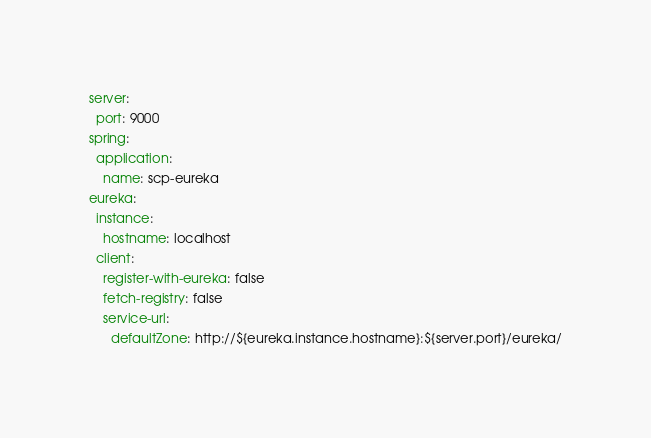<code> <loc_0><loc_0><loc_500><loc_500><_YAML_>server:
  port: 9000
spring:
  application:
    name: scp-eureka
eureka:
  instance:
    hostname: localhost
  client:
    register-with-eureka: false
    fetch-registry: false
    service-url:
      defaultZone: http://${eureka.instance.hostname}:${server.port}/eureka/

</code> 